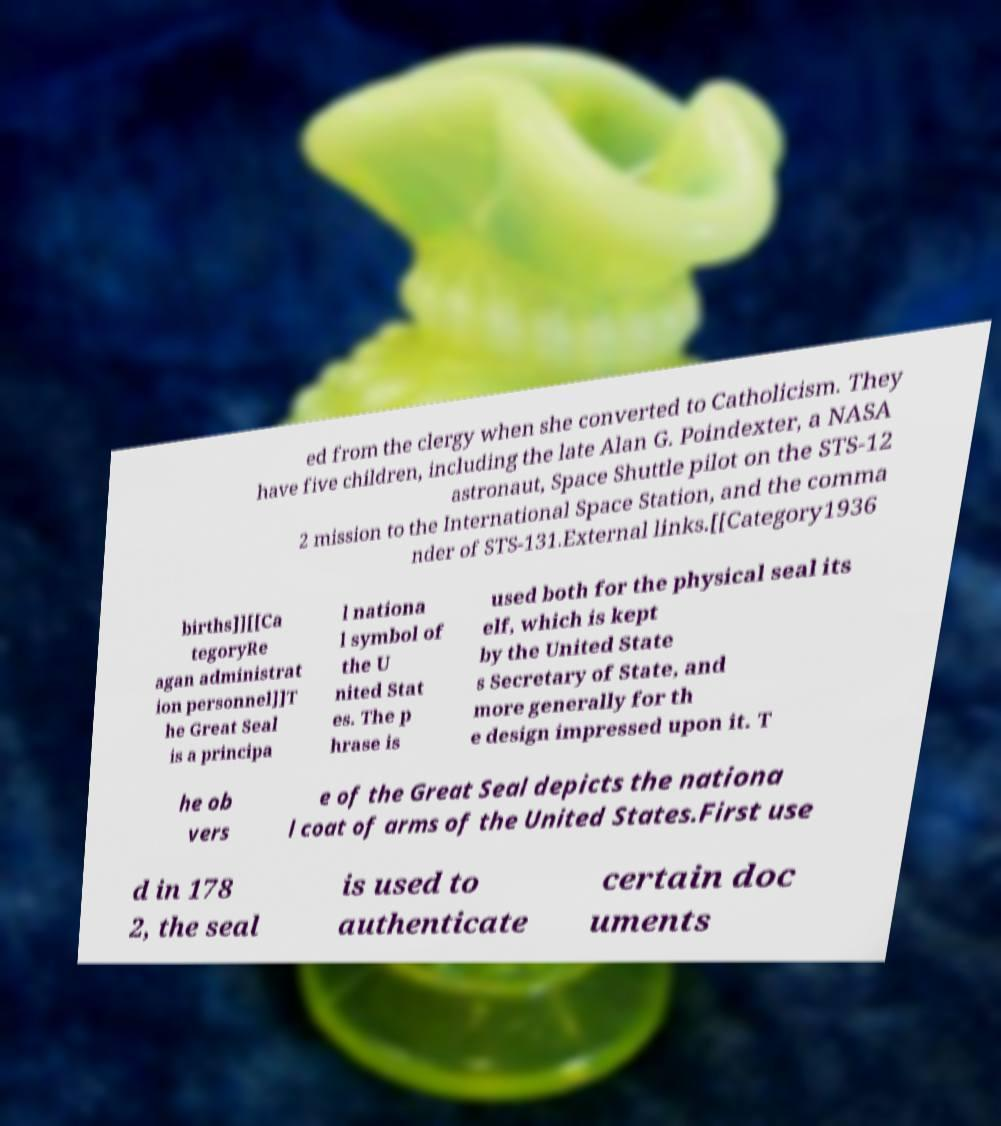For documentation purposes, I need the text within this image transcribed. Could you provide that? ed from the clergy when she converted to Catholicism. They have five children, including the late Alan G. Poindexter, a NASA astronaut, Space Shuttle pilot on the STS-12 2 mission to the International Space Station, and the comma nder of STS-131.External links.[[Category1936 births]][[Ca tegoryRe agan administrat ion personnel]]T he Great Seal is a principa l nationa l symbol of the U nited Stat es. The p hrase is used both for the physical seal its elf, which is kept by the United State s Secretary of State, and more generally for th e design impressed upon it. T he ob vers e of the Great Seal depicts the nationa l coat of arms of the United States.First use d in 178 2, the seal is used to authenticate certain doc uments 